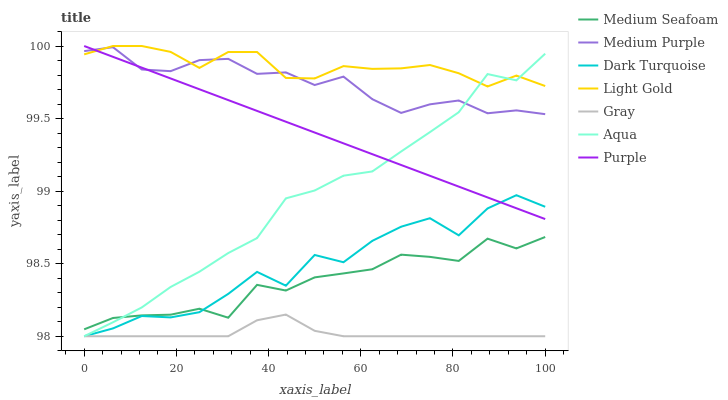Does Gray have the minimum area under the curve?
Answer yes or no. Yes. Does Light Gold have the maximum area under the curve?
Answer yes or no. Yes. Does Purple have the minimum area under the curve?
Answer yes or no. No. Does Purple have the maximum area under the curve?
Answer yes or no. No. Is Purple the smoothest?
Answer yes or no. Yes. Is Dark Turquoise the roughest?
Answer yes or no. Yes. Is Dark Turquoise the smoothest?
Answer yes or no. No. Is Purple the roughest?
Answer yes or no. No. Does Purple have the lowest value?
Answer yes or no. No. Does Light Gold have the highest value?
Answer yes or no. Yes. Does Dark Turquoise have the highest value?
Answer yes or no. No. Is Dark Turquoise less than Medium Purple?
Answer yes or no. Yes. Is Medium Seafoam greater than Gray?
Answer yes or no. Yes. Does Dark Turquoise intersect Medium Purple?
Answer yes or no. No. 